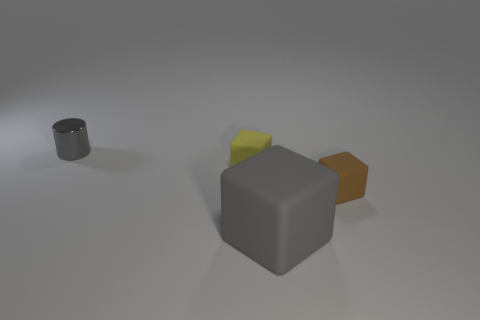Are there fewer small yellow matte cubes behind the metal object than brown rubber things?
Offer a very short reply. Yes. What is the shape of the large gray thing?
Ensure brevity in your answer.  Cube. There is a cube that is in front of the tiny brown block; what size is it?
Offer a terse response. Large. What is the color of the cylinder that is the same size as the brown matte cube?
Your response must be concise. Gray. Are there any other objects of the same color as the large rubber object?
Provide a succinct answer. Yes. Are there fewer tiny yellow blocks that are to the left of the small yellow matte cube than small things behind the metal thing?
Your response must be concise. No. There is a big gray object; is its shape the same as the tiny matte object that is on the left side of the small brown rubber block?
Make the answer very short. Yes. What number of other things are the same size as the gray metal cylinder?
Keep it short and to the point. 2. Is the number of large rubber objects greater than the number of big cyan metal cylinders?
Ensure brevity in your answer.  Yes. What number of small objects are to the left of the small yellow cube and in front of the tiny gray thing?
Make the answer very short. 0. 